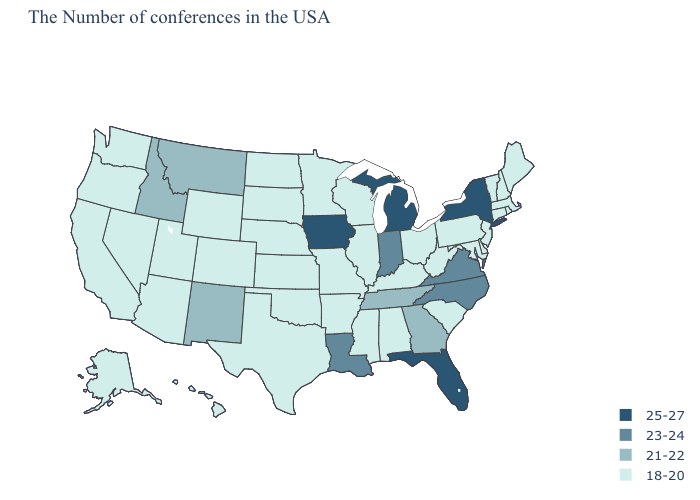Does West Virginia have the highest value in the South?
Keep it brief. No. Name the states that have a value in the range 23-24?
Write a very short answer. Virginia, North Carolina, Indiana, Louisiana. What is the value of Kentucky?
Short answer required. 18-20. Name the states that have a value in the range 21-22?
Give a very brief answer. Georgia, Tennessee, New Mexico, Montana, Idaho. What is the value of Michigan?
Concise answer only. 25-27. What is the lowest value in the USA?
Short answer required. 18-20. Name the states that have a value in the range 18-20?
Give a very brief answer. Maine, Massachusetts, Rhode Island, New Hampshire, Vermont, Connecticut, New Jersey, Delaware, Maryland, Pennsylvania, South Carolina, West Virginia, Ohio, Kentucky, Alabama, Wisconsin, Illinois, Mississippi, Missouri, Arkansas, Minnesota, Kansas, Nebraska, Oklahoma, Texas, South Dakota, North Dakota, Wyoming, Colorado, Utah, Arizona, Nevada, California, Washington, Oregon, Alaska, Hawaii. What is the value of Oklahoma?
Concise answer only. 18-20. Among the states that border South Dakota , does Montana have the lowest value?
Be succinct. No. Among the states that border Wyoming , which have the lowest value?
Keep it brief. Nebraska, South Dakota, Colorado, Utah. What is the lowest value in states that border Iowa?
Write a very short answer. 18-20. Name the states that have a value in the range 21-22?
Be succinct. Georgia, Tennessee, New Mexico, Montana, Idaho. What is the value of Montana?
Concise answer only. 21-22. Among the states that border Georgia , which have the highest value?
Short answer required. Florida. Name the states that have a value in the range 25-27?
Answer briefly. New York, Florida, Michigan, Iowa. 